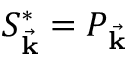Convert formula to latex. <formula><loc_0><loc_0><loc_500><loc_500>S _ { \vec { k } } ^ { * } = P _ { \vec { k } }</formula> 